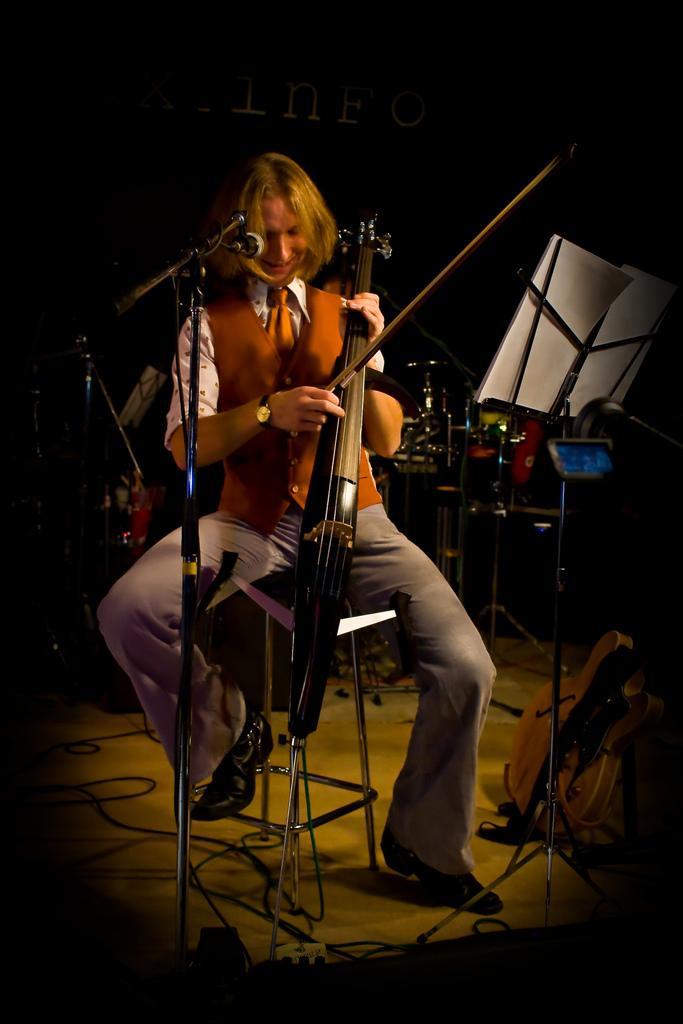How would you summarize this image in a sentence or two? Here we can see a person playing musical instrument and this is mike. This is floor. In the background we can see some musical instruments. 